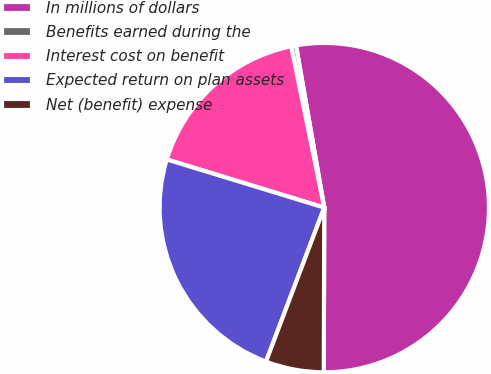Convert chart. <chart><loc_0><loc_0><loc_500><loc_500><pie_chart><fcel>In millions of dollars<fcel>Benefits earned during the<fcel>Interest cost on benefit<fcel>Expected return on plan assets<fcel>Net (benefit) expense<nl><fcel>52.8%<fcel>0.47%<fcel>17.06%<fcel>23.97%<fcel>5.71%<nl></chart> 